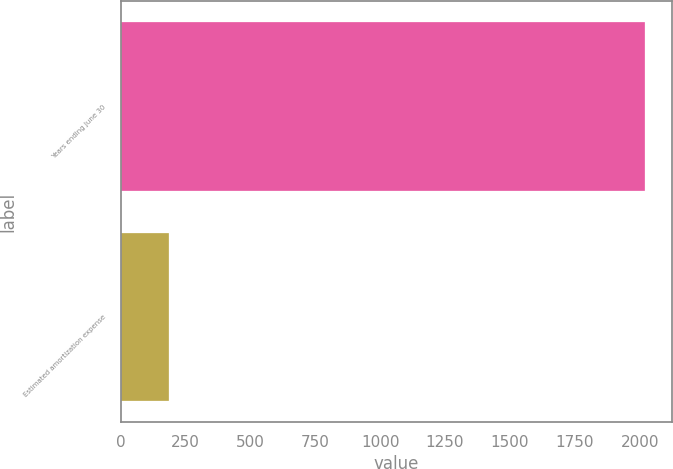Convert chart to OTSL. <chart><loc_0><loc_0><loc_500><loc_500><bar_chart><fcel>Years ending June 30<fcel>Estimated amortization expense<nl><fcel>2022<fcel>185<nl></chart> 